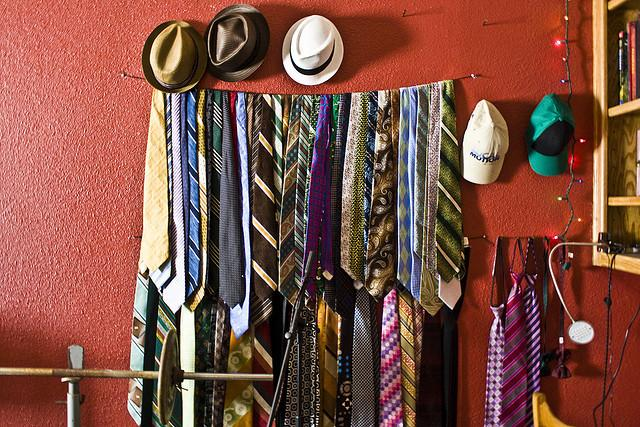Who does this room belong to? man 